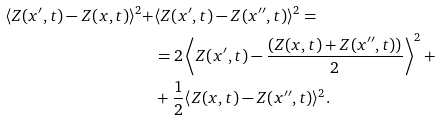Convert formula to latex. <formula><loc_0><loc_0><loc_500><loc_500>\langle Z ( x ^ { \prime } , t ) - Z ( x , t ) \rangle ^ { 2 } + & \langle Z ( x ^ { \prime } , t ) - Z ( x ^ { \prime \prime } , t ) \rangle ^ { 2 } = \\ & = 2 \left \langle Z ( x ^ { \prime } , t ) - \frac { ( Z ( x , t ) + Z ( x ^ { \prime \prime } , t ) ) } { 2 } \right \rangle ^ { 2 } + \\ & + \frac { 1 } { 2 } \langle Z ( x , t ) - Z ( x ^ { \prime \prime } , t ) \rangle ^ { 2 } .</formula> 